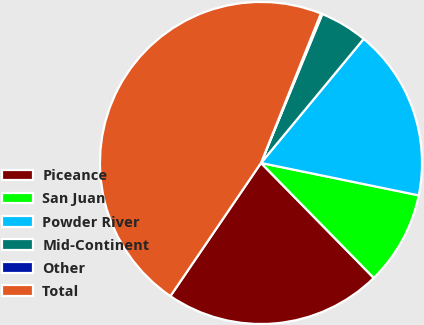Convert chart. <chart><loc_0><loc_0><loc_500><loc_500><pie_chart><fcel>Piceance<fcel>San Juan<fcel>Powder River<fcel>Mid-Continent<fcel>Other<fcel>Total<nl><fcel>21.86%<fcel>9.43%<fcel>17.22%<fcel>4.79%<fcel>0.15%<fcel>46.56%<nl></chart> 